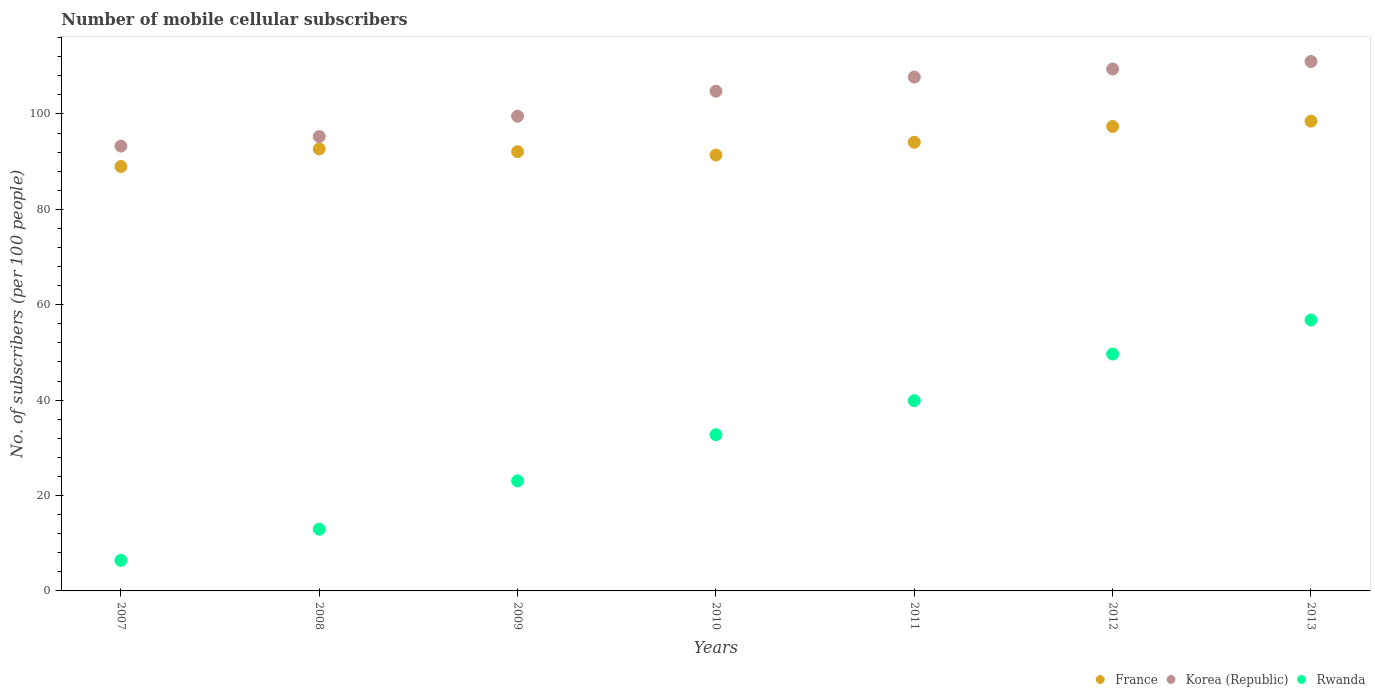How many different coloured dotlines are there?
Offer a terse response. 3. What is the number of mobile cellular subscribers in France in 2010?
Provide a succinct answer. 91.39. Across all years, what is the maximum number of mobile cellular subscribers in Korea (Republic)?
Offer a very short reply. 111. Across all years, what is the minimum number of mobile cellular subscribers in France?
Your response must be concise. 88.98. In which year was the number of mobile cellular subscribers in France maximum?
Make the answer very short. 2013. In which year was the number of mobile cellular subscribers in Korea (Republic) minimum?
Offer a very short reply. 2007. What is the total number of mobile cellular subscribers in Rwanda in the graph?
Your response must be concise. 221.52. What is the difference between the number of mobile cellular subscribers in France in 2008 and that in 2011?
Provide a short and direct response. -1.4. What is the difference between the number of mobile cellular subscribers in Rwanda in 2012 and the number of mobile cellular subscribers in France in 2010?
Ensure brevity in your answer.  -41.72. What is the average number of mobile cellular subscribers in Korea (Republic) per year?
Provide a succinct answer. 103. In the year 2012, what is the difference between the number of mobile cellular subscribers in Korea (Republic) and number of mobile cellular subscribers in Rwanda?
Your response must be concise. 59.76. In how many years, is the number of mobile cellular subscribers in Korea (Republic) greater than 24?
Give a very brief answer. 7. What is the ratio of the number of mobile cellular subscribers in France in 2009 to that in 2012?
Offer a terse response. 0.95. What is the difference between the highest and the second highest number of mobile cellular subscribers in Rwanda?
Give a very brief answer. 7.13. What is the difference between the highest and the lowest number of mobile cellular subscribers in Rwanda?
Your answer should be very brief. 50.4. In how many years, is the number of mobile cellular subscribers in France greater than the average number of mobile cellular subscribers in France taken over all years?
Make the answer very short. 3. Is the sum of the number of mobile cellular subscribers in Korea (Republic) in 2009 and 2010 greater than the maximum number of mobile cellular subscribers in France across all years?
Ensure brevity in your answer.  Yes. Is it the case that in every year, the sum of the number of mobile cellular subscribers in France and number of mobile cellular subscribers in Rwanda  is greater than the number of mobile cellular subscribers in Korea (Republic)?
Ensure brevity in your answer.  Yes. Is the number of mobile cellular subscribers in Korea (Republic) strictly greater than the number of mobile cellular subscribers in France over the years?
Your answer should be very brief. Yes. How many dotlines are there?
Your answer should be very brief. 3. How many years are there in the graph?
Offer a very short reply. 7. Are the values on the major ticks of Y-axis written in scientific E-notation?
Offer a terse response. No. How many legend labels are there?
Provide a succinct answer. 3. How are the legend labels stacked?
Offer a very short reply. Horizontal. What is the title of the graph?
Ensure brevity in your answer.  Number of mobile cellular subscribers. Does "Spain" appear as one of the legend labels in the graph?
Your answer should be compact. No. What is the label or title of the Y-axis?
Provide a succinct answer. No. of subscribers (per 100 people). What is the No. of subscribers (per 100 people) in France in 2007?
Offer a very short reply. 88.98. What is the No. of subscribers (per 100 people) in Korea (Republic) in 2007?
Offer a terse response. 93.27. What is the No. of subscribers (per 100 people) of Rwanda in 2007?
Give a very brief answer. 6.4. What is the No. of subscribers (per 100 people) in France in 2008?
Provide a short and direct response. 92.68. What is the No. of subscribers (per 100 people) in Korea (Republic) in 2008?
Offer a terse response. 95.28. What is the No. of subscribers (per 100 people) in Rwanda in 2008?
Offer a very short reply. 12.94. What is the No. of subscribers (per 100 people) of France in 2009?
Make the answer very short. 92.1. What is the No. of subscribers (per 100 people) in Korea (Republic) in 2009?
Your answer should be very brief. 99.54. What is the No. of subscribers (per 100 people) in Rwanda in 2009?
Your answer should be compact. 23.07. What is the No. of subscribers (per 100 people) of France in 2010?
Offer a very short reply. 91.39. What is the No. of subscribers (per 100 people) in Korea (Republic) in 2010?
Offer a very short reply. 104.77. What is the No. of subscribers (per 100 people) of Rwanda in 2010?
Offer a very short reply. 32.75. What is the No. of subscribers (per 100 people) of France in 2011?
Offer a very short reply. 94.08. What is the No. of subscribers (per 100 people) of Korea (Republic) in 2011?
Offer a very short reply. 107.74. What is the No. of subscribers (per 100 people) in Rwanda in 2011?
Offer a very short reply. 39.9. What is the No. of subscribers (per 100 people) in France in 2012?
Provide a short and direct response. 97.38. What is the No. of subscribers (per 100 people) of Korea (Republic) in 2012?
Make the answer very short. 109.43. What is the No. of subscribers (per 100 people) in Rwanda in 2012?
Make the answer very short. 49.67. What is the No. of subscribers (per 100 people) in France in 2013?
Ensure brevity in your answer.  98.5. What is the No. of subscribers (per 100 people) of Korea (Republic) in 2013?
Give a very brief answer. 111. What is the No. of subscribers (per 100 people) of Rwanda in 2013?
Make the answer very short. 56.8. Across all years, what is the maximum No. of subscribers (per 100 people) in France?
Your response must be concise. 98.5. Across all years, what is the maximum No. of subscribers (per 100 people) in Korea (Republic)?
Offer a very short reply. 111. Across all years, what is the maximum No. of subscribers (per 100 people) of Rwanda?
Your response must be concise. 56.8. Across all years, what is the minimum No. of subscribers (per 100 people) in France?
Provide a succinct answer. 88.98. Across all years, what is the minimum No. of subscribers (per 100 people) in Korea (Republic)?
Provide a short and direct response. 93.27. Across all years, what is the minimum No. of subscribers (per 100 people) in Rwanda?
Make the answer very short. 6.4. What is the total No. of subscribers (per 100 people) in France in the graph?
Provide a succinct answer. 655.1. What is the total No. of subscribers (per 100 people) in Korea (Republic) in the graph?
Ensure brevity in your answer.  721.03. What is the total No. of subscribers (per 100 people) in Rwanda in the graph?
Your response must be concise. 221.52. What is the difference between the No. of subscribers (per 100 people) of France in 2007 and that in 2008?
Keep it short and to the point. -3.69. What is the difference between the No. of subscribers (per 100 people) in Korea (Republic) in 2007 and that in 2008?
Give a very brief answer. -2.01. What is the difference between the No. of subscribers (per 100 people) of Rwanda in 2007 and that in 2008?
Your response must be concise. -6.54. What is the difference between the No. of subscribers (per 100 people) of France in 2007 and that in 2009?
Your answer should be very brief. -3.11. What is the difference between the No. of subscribers (per 100 people) of Korea (Republic) in 2007 and that in 2009?
Keep it short and to the point. -6.28. What is the difference between the No. of subscribers (per 100 people) in Rwanda in 2007 and that in 2009?
Offer a terse response. -16.67. What is the difference between the No. of subscribers (per 100 people) of France in 2007 and that in 2010?
Ensure brevity in your answer.  -2.4. What is the difference between the No. of subscribers (per 100 people) of Korea (Republic) in 2007 and that in 2010?
Offer a very short reply. -11.51. What is the difference between the No. of subscribers (per 100 people) of Rwanda in 2007 and that in 2010?
Provide a succinct answer. -26.35. What is the difference between the No. of subscribers (per 100 people) of France in 2007 and that in 2011?
Your response must be concise. -5.09. What is the difference between the No. of subscribers (per 100 people) of Korea (Republic) in 2007 and that in 2011?
Make the answer very short. -14.48. What is the difference between the No. of subscribers (per 100 people) of Rwanda in 2007 and that in 2011?
Ensure brevity in your answer.  -33.5. What is the difference between the No. of subscribers (per 100 people) of France in 2007 and that in 2012?
Keep it short and to the point. -8.39. What is the difference between the No. of subscribers (per 100 people) in Korea (Republic) in 2007 and that in 2012?
Your answer should be compact. -16.17. What is the difference between the No. of subscribers (per 100 people) of Rwanda in 2007 and that in 2012?
Provide a succinct answer. -43.27. What is the difference between the No. of subscribers (per 100 people) of France in 2007 and that in 2013?
Your answer should be very brief. -9.51. What is the difference between the No. of subscribers (per 100 people) of Korea (Republic) in 2007 and that in 2013?
Ensure brevity in your answer.  -17.73. What is the difference between the No. of subscribers (per 100 people) of Rwanda in 2007 and that in 2013?
Keep it short and to the point. -50.4. What is the difference between the No. of subscribers (per 100 people) in France in 2008 and that in 2009?
Make the answer very short. 0.58. What is the difference between the No. of subscribers (per 100 people) of Korea (Republic) in 2008 and that in 2009?
Offer a terse response. -4.27. What is the difference between the No. of subscribers (per 100 people) in Rwanda in 2008 and that in 2009?
Provide a succinct answer. -10.13. What is the difference between the No. of subscribers (per 100 people) of France in 2008 and that in 2010?
Give a very brief answer. 1.29. What is the difference between the No. of subscribers (per 100 people) in Korea (Republic) in 2008 and that in 2010?
Offer a terse response. -9.5. What is the difference between the No. of subscribers (per 100 people) in Rwanda in 2008 and that in 2010?
Offer a terse response. -19.81. What is the difference between the No. of subscribers (per 100 people) of France in 2008 and that in 2011?
Give a very brief answer. -1.4. What is the difference between the No. of subscribers (per 100 people) in Korea (Republic) in 2008 and that in 2011?
Give a very brief answer. -12.47. What is the difference between the No. of subscribers (per 100 people) in Rwanda in 2008 and that in 2011?
Offer a very short reply. -26.96. What is the difference between the No. of subscribers (per 100 people) in France in 2008 and that in 2012?
Offer a terse response. -4.7. What is the difference between the No. of subscribers (per 100 people) in Korea (Republic) in 2008 and that in 2012?
Provide a short and direct response. -14.15. What is the difference between the No. of subscribers (per 100 people) of Rwanda in 2008 and that in 2012?
Offer a terse response. -36.73. What is the difference between the No. of subscribers (per 100 people) in France in 2008 and that in 2013?
Ensure brevity in your answer.  -5.82. What is the difference between the No. of subscribers (per 100 people) of Korea (Republic) in 2008 and that in 2013?
Offer a very short reply. -15.72. What is the difference between the No. of subscribers (per 100 people) in Rwanda in 2008 and that in 2013?
Your answer should be very brief. -43.86. What is the difference between the No. of subscribers (per 100 people) of France in 2009 and that in 2010?
Offer a very short reply. 0.71. What is the difference between the No. of subscribers (per 100 people) in Korea (Republic) in 2009 and that in 2010?
Provide a succinct answer. -5.23. What is the difference between the No. of subscribers (per 100 people) of Rwanda in 2009 and that in 2010?
Your answer should be compact. -9.68. What is the difference between the No. of subscribers (per 100 people) of France in 2009 and that in 2011?
Offer a terse response. -1.98. What is the difference between the No. of subscribers (per 100 people) of Korea (Republic) in 2009 and that in 2011?
Make the answer very short. -8.2. What is the difference between the No. of subscribers (per 100 people) in Rwanda in 2009 and that in 2011?
Provide a succinct answer. -16.83. What is the difference between the No. of subscribers (per 100 people) in France in 2009 and that in 2012?
Ensure brevity in your answer.  -5.28. What is the difference between the No. of subscribers (per 100 people) in Korea (Republic) in 2009 and that in 2012?
Your answer should be very brief. -9.89. What is the difference between the No. of subscribers (per 100 people) of Rwanda in 2009 and that in 2012?
Make the answer very short. -26.6. What is the difference between the No. of subscribers (per 100 people) of France in 2009 and that in 2013?
Provide a short and direct response. -6.4. What is the difference between the No. of subscribers (per 100 people) in Korea (Republic) in 2009 and that in 2013?
Keep it short and to the point. -11.46. What is the difference between the No. of subscribers (per 100 people) in Rwanda in 2009 and that in 2013?
Provide a short and direct response. -33.73. What is the difference between the No. of subscribers (per 100 people) in France in 2010 and that in 2011?
Provide a short and direct response. -2.69. What is the difference between the No. of subscribers (per 100 people) of Korea (Republic) in 2010 and that in 2011?
Give a very brief answer. -2.97. What is the difference between the No. of subscribers (per 100 people) of Rwanda in 2010 and that in 2011?
Ensure brevity in your answer.  -7.15. What is the difference between the No. of subscribers (per 100 people) in France in 2010 and that in 2012?
Provide a succinct answer. -5.99. What is the difference between the No. of subscribers (per 100 people) of Korea (Republic) in 2010 and that in 2012?
Give a very brief answer. -4.66. What is the difference between the No. of subscribers (per 100 people) in Rwanda in 2010 and that in 2012?
Ensure brevity in your answer.  -16.92. What is the difference between the No. of subscribers (per 100 people) of France in 2010 and that in 2013?
Provide a short and direct response. -7.11. What is the difference between the No. of subscribers (per 100 people) in Korea (Republic) in 2010 and that in 2013?
Offer a very short reply. -6.22. What is the difference between the No. of subscribers (per 100 people) of Rwanda in 2010 and that in 2013?
Provide a succinct answer. -24.05. What is the difference between the No. of subscribers (per 100 people) in France in 2011 and that in 2012?
Your response must be concise. -3.3. What is the difference between the No. of subscribers (per 100 people) in Korea (Republic) in 2011 and that in 2012?
Your answer should be compact. -1.69. What is the difference between the No. of subscribers (per 100 people) in Rwanda in 2011 and that in 2012?
Offer a very short reply. -9.77. What is the difference between the No. of subscribers (per 100 people) of France in 2011 and that in 2013?
Your response must be concise. -4.42. What is the difference between the No. of subscribers (per 100 people) in Korea (Republic) in 2011 and that in 2013?
Ensure brevity in your answer.  -3.25. What is the difference between the No. of subscribers (per 100 people) in Rwanda in 2011 and that in 2013?
Keep it short and to the point. -16.9. What is the difference between the No. of subscribers (per 100 people) of France in 2012 and that in 2013?
Keep it short and to the point. -1.12. What is the difference between the No. of subscribers (per 100 people) in Korea (Republic) in 2012 and that in 2013?
Ensure brevity in your answer.  -1.57. What is the difference between the No. of subscribers (per 100 people) of Rwanda in 2012 and that in 2013?
Offer a terse response. -7.13. What is the difference between the No. of subscribers (per 100 people) in France in 2007 and the No. of subscribers (per 100 people) in Korea (Republic) in 2008?
Offer a very short reply. -6.29. What is the difference between the No. of subscribers (per 100 people) of France in 2007 and the No. of subscribers (per 100 people) of Rwanda in 2008?
Give a very brief answer. 76.05. What is the difference between the No. of subscribers (per 100 people) in Korea (Republic) in 2007 and the No. of subscribers (per 100 people) in Rwanda in 2008?
Ensure brevity in your answer.  80.33. What is the difference between the No. of subscribers (per 100 people) of France in 2007 and the No. of subscribers (per 100 people) of Korea (Republic) in 2009?
Give a very brief answer. -10.56. What is the difference between the No. of subscribers (per 100 people) in France in 2007 and the No. of subscribers (per 100 people) in Rwanda in 2009?
Ensure brevity in your answer.  65.91. What is the difference between the No. of subscribers (per 100 people) of Korea (Republic) in 2007 and the No. of subscribers (per 100 people) of Rwanda in 2009?
Offer a terse response. 70.2. What is the difference between the No. of subscribers (per 100 people) of France in 2007 and the No. of subscribers (per 100 people) of Korea (Republic) in 2010?
Provide a short and direct response. -15.79. What is the difference between the No. of subscribers (per 100 people) of France in 2007 and the No. of subscribers (per 100 people) of Rwanda in 2010?
Provide a succinct answer. 56.24. What is the difference between the No. of subscribers (per 100 people) of Korea (Republic) in 2007 and the No. of subscribers (per 100 people) of Rwanda in 2010?
Make the answer very short. 60.52. What is the difference between the No. of subscribers (per 100 people) in France in 2007 and the No. of subscribers (per 100 people) in Korea (Republic) in 2011?
Offer a very short reply. -18.76. What is the difference between the No. of subscribers (per 100 people) of France in 2007 and the No. of subscribers (per 100 people) of Rwanda in 2011?
Ensure brevity in your answer.  49.09. What is the difference between the No. of subscribers (per 100 people) of Korea (Republic) in 2007 and the No. of subscribers (per 100 people) of Rwanda in 2011?
Your answer should be very brief. 53.37. What is the difference between the No. of subscribers (per 100 people) in France in 2007 and the No. of subscribers (per 100 people) in Korea (Republic) in 2012?
Your answer should be compact. -20.45. What is the difference between the No. of subscribers (per 100 people) in France in 2007 and the No. of subscribers (per 100 people) in Rwanda in 2012?
Keep it short and to the point. 39.32. What is the difference between the No. of subscribers (per 100 people) in Korea (Republic) in 2007 and the No. of subscribers (per 100 people) in Rwanda in 2012?
Provide a short and direct response. 43.6. What is the difference between the No. of subscribers (per 100 people) of France in 2007 and the No. of subscribers (per 100 people) of Korea (Republic) in 2013?
Provide a succinct answer. -22.01. What is the difference between the No. of subscribers (per 100 people) of France in 2007 and the No. of subscribers (per 100 people) of Rwanda in 2013?
Offer a very short reply. 32.18. What is the difference between the No. of subscribers (per 100 people) of Korea (Republic) in 2007 and the No. of subscribers (per 100 people) of Rwanda in 2013?
Provide a succinct answer. 36.47. What is the difference between the No. of subscribers (per 100 people) in France in 2008 and the No. of subscribers (per 100 people) in Korea (Republic) in 2009?
Ensure brevity in your answer.  -6.86. What is the difference between the No. of subscribers (per 100 people) in France in 2008 and the No. of subscribers (per 100 people) in Rwanda in 2009?
Make the answer very short. 69.61. What is the difference between the No. of subscribers (per 100 people) in Korea (Republic) in 2008 and the No. of subscribers (per 100 people) in Rwanda in 2009?
Offer a terse response. 72.21. What is the difference between the No. of subscribers (per 100 people) of France in 2008 and the No. of subscribers (per 100 people) of Korea (Republic) in 2010?
Make the answer very short. -12.1. What is the difference between the No. of subscribers (per 100 people) of France in 2008 and the No. of subscribers (per 100 people) of Rwanda in 2010?
Provide a short and direct response. 59.93. What is the difference between the No. of subscribers (per 100 people) in Korea (Republic) in 2008 and the No. of subscribers (per 100 people) in Rwanda in 2010?
Your answer should be compact. 62.53. What is the difference between the No. of subscribers (per 100 people) of France in 2008 and the No. of subscribers (per 100 people) of Korea (Republic) in 2011?
Your answer should be compact. -15.07. What is the difference between the No. of subscribers (per 100 people) of France in 2008 and the No. of subscribers (per 100 people) of Rwanda in 2011?
Ensure brevity in your answer.  52.78. What is the difference between the No. of subscribers (per 100 people) in Korea (Republic) in 2008 and the No. of subscribers (per 100 people) in Rwanda in 2011?
Offer a terse response. 55.38. What is the difference between the No. of subscribers (per 100 people) in France in 2008 and the No. of subscribers (per 100 people) in Korea (Republic) in 2012?
Your response must be concise. -16.75. What is the difference between the No. of subscribers (per 100 people) in France in 2008 and the No. of subscribers (per 100 people) in Rwanda in 2012?
Your answer should be very brief. 43.01. What is the difference between the No. of subscribers (per 100 people) of Korea (Republic) in 2008 and the No. of subscribers (per 100 people) of Rwanda in 2012?
Provide a short and direct response. 45.61. What is the difference between the No. of subscribers (per 100 people) in France in 2008 and the No. of subscribers (per 100 people) in Korea (Republic) in 2013?
Provide a short and direct response. -18.32. What is the difference between the No. of subscribers (per 100 people) of France in 2008 and the No. of subscribers (per 100 people) of Rwanda in 2013?
Your response must be concise. 35.88. What is the difference between the No. of subscribers (per 100 people) of Korea (Republic) in 2008 and the No. of subscribers (per 100 people) of Rwanda in 2013?
Keep it short and to the point. 38.48. What is the difference between the No. of subscribers (per 100 people) in France in 2009 and the No. of subscribers (per 100 people) in Korea (Republic) in 2010?
Your answer should be compact. -12.68. What is the difference between the No. of subscribers (per 100 people) of France in 2009 and the No. of subscribers (per 100 people) of Rwanda in 2010?
Offer a very short reply. 59.35. What is the difference between the No. of subscribers (per 100 people) of Korea (Republic) in 2009 and the No. of subscribers (per 100 people) of Rwanda in 2010?
Make the answer very short. 66.79. What is the difference between the No. of subscribers (per 100 people) of France in 2009 and the No. of subscribers (per 100 people) of Korea (Republic) in 2011?
Offer a terse response. -15.65. What is the difference between the No. of subscribers (per 100 people) in France in 2009 and the No. of subscribers (per 100 people) in Rwanda in 2011?
Your answer should be compact. 52.2. What is the difference between the No. of subscribers (per 100 people) in Korea (Republic) in 2009 and the No. of subscribers (per 100 people) in Rwanda in 2011?
Provide a short and direct response. 59.65. What is the difference between the No. of subscribers (per 100 people) in France in 2009 and the No. of subscribers (per 100 people) in Korea (Republic) in 2012?
Make the answer very short. -17.34. What is the difference between the No. of subscribers (per 100 people) of France in 2009 and the No. of subscribers (per 100 people) of Rwanda in 2012?
Give a very brief answer. 42.43. What is the difference between the No. of subscribers (per 100 people) in Korea (Republic) in 2009 and the No. of subscribers (per 100 people) in Rwanda in 2012?
Your response must be concise. 49.87. What is the difference between the No. of subscribers (per 100 people) in France in 2009 and the No. of subscribers (per 100 people) in Korea (Republic) in 2013?
Your answer should be very brief. -18.9. What is the difference between the No. of subscribers (per 100 people) of France in 2009 and the No. of subscribers (per 100 people) of Rwanda in 2013?
Give a very brief answer. 35.3. What is the difference between the No. of subscribers (per 100 people) in Korea (Republic) in 2009 and the No. of subscribers (per 100 people) in Rwanda in 2013?
Offer a terse response. 42.74. What is the difference between the No. of subscribers (per 100 people) of France in 2010 and the No. of subscribers (per 100 people) of Korea (Republic) in 2011?
Your response must be concise. -16.36. What is the difference between the No. of subscribers (per 100 people) in France in 2010 and the No. of subscribers (per 100 people) in Rwanda in 2011?
Your answer should be compact. 51.49. What is the difference between the No. of subscribers (per 100 people) of Korea (Republic) in 2010 and the No. of subscribers (per 100 people) of Rwanda in 2011?
Ensure brevity in your answer.  64.88. What is the difference between the No. of subscribers (per 100 people) in France in 2010 and the No. of subscribers (per 100 people) in Korea (Republic) in 2012?
Keep it short and to the point. -18.04. What is the difference between the No. of subscribers (per 100 people) of France in 2010 and the No. of subscribers (per 100 people) of Rwanda in 2012?
Keep it short and to the point. 41.72. What is the difference between the No. of subscribers (per 100 people) in Korea (Republic) in 2010 and the No. of subscribers (per 100 people) in Rwanda in 2012?
Your answer should be compact. 55.11. What is the difference between the No. of subscribers (per 100 people) in France in 2010 and the No. of subscribers (per 100 people) in Korea (Republic) in 2013?
Offer a terse response. -19.61. What is the difference between the No. of subscribers (per 100 people) in France in 2010 and the No. of subscribers (per 100 people) in Rwanda in 2013?
Keep it short and to the point. 34.59. What is the difference between the No. of subscribers (per 100 people) in Korea (Republic) in 2010 and the No. of subscribers (per 100 people) in Rwanda in 2013?
Your answer should be very brief. 47.97. What is the difference between the No. of subscribers (per 100 people) in France in 2011 and the No. of subscribers (per 100 people) in Korea (Republic) in 2012?
Your answer should be very brief. -15.35. What is the difference between the No. of subscribers (per 100 people) of France in 2011 and the No. of subscribers (per 100 people) of Rwanda in 2012?
Make the answer very short. 44.41. What is the difference between the No. of subscribers (per 100 people) of Korea (Republic) in 2011 and the No. of subscribers (per 100 people) of Rwanda in 2012?
Keep it short and to the point. 58.08. What is the difference between the No. of subscribers (per 100 people) of France in 2011 and the No. of subscribers (per 100 people) of Korea (Republic) in 2013?
Keep it short and to the point. -16.92. What is the difference between the No. of subscribers (per 100 people) of France in 2011 and the No. of subscribers (per 100 people) of Rwanda in 2013?
Provide a succinct answer. 37.28. What is the difference between the No. of subscribers (per 100 people) in Korea (Republic) in 2011 and the No. of subscribers (per 100 people) in Rwanda in 2013?
Your answer should be very brief. 50.94. What is the difference between the No. of subscribers (per 100 people) in France in 2012 and the No. of subscribers (per 100 people) in Korea (Republic) in 2013?
Offer a very short reply. -13.62. What is the difference between the No. of subscribers (per 100 people) of France in 2012 and the No. of subscribers (per 100 people) of Rwanda in 2013?
Make the answer very short. 40.58. What is the difference between the No. of subscribers (per 100 people) of Korea (Republic) in 2012 and the No. of subscribers (per 100 people) of Rwanda in 2013?
Offer a very short reply. 52.63. What is the average No. of subscribers (per 100 people) of France per year?
Provide a short and direct response. 93.59. What is the average No. of subscribers (per 100 people) in Korea (Republic) per year?
Offer a terse response. 103. What is the average No. of subscribers (per 100 people) in Rwanda per year?
Ensure brevity in your answer.  31.65. In the year 2007, what is the difference between the No. of subscribers (per 100 people) of France and No. of subscribers (per 100 people) of Korea (Republic)?
Make the answer very short. -4.28. In the year 2007, what is the difference between the No. of subscribers (per 100 people) in France and No. of subscribers (per 100 people) in Rwanda?
Ensure brevity in your answer.  82.59. In the year 2007, what is the difference between the No. of subscribers (per 100 people) in Korea (Republic) and No. of subscribers (per 100 people) in Rwanda?
Ensure brevity in your answer.  86.87. In the year 2008, what is the difference between the No. of subscribers (per 100 people) in France and No. of subscribers (per 100 people) in Korea (Republic)?
Offer a very short reply. -2.6. In the year 2008, what is the difference between the No. of subscribers (per 100 people) of France and No. of subscribers (per 100 people) of Rwanda?
Provide a succinct answer. 79.74. In the year 2008, what is the difference between the No. of subscribers (per 100 people) in Korea (Republic) and No. of subscribers (per 100 people) in Rwanda?
Offer a terse response. 82.34. In the year 2009, what is the difference between the No. of subscribers (per 100 people) of France and No. of subscribers (per 100 people) of Korea (Republic)?
Provide a short and direct response. -7.45. In the year 2009, what is the difference between the No. of subscribers (per 100 people) of France and No. of subscribers (per 100 people) of Rwanda?
Provide a succinct answer. 69.03. In the year 2009, what is the difference between the No. of subscribers (per 100 people) in Korea (Republic) and No. of subscribers (per 100 people) in Rwanda?
Your response must be concise. 76.47. In the year 2010, what is the difference between the No. of subscribers (per 100 people) in France and No. of subscribers (per 100 people) in Korea (Republic)?
Make the answer very short. -13.39. In the year 2010, what is the difference between the No. of subscribers (per 100 people) in France and No. of subscribers (per 100 people) in Rwanda?
Offer a very short reply. 58.64. In the year 2010, what is the difference between the No. of subscribers (per 100 people) in Korea (Republic) and No. of subscribers (per 100 people) in Rwanda?
Ensure brevity in your answer.  72.03. In the year 2011, what is the difference between the No. of subscribers (per 100 people) in France and No. of subscribers (per 100 people) in Korea (Republic)?
Give a very brief answer. -13.67. In the year 2011, what is the difference between the No. of subscribers (per 100 people) in France and No. of subscribers (per 100 people) in Rwanda?
Ensure brevity in your answer.  54.18. In the year 2011, what is the difference between the No. of subscribers (per 100 people) in Korea (Republic) and No. of subscribers (per 100 people) in Rwanda?
Your answer should be compact. 67.85. In the year 2012, what is the difference between the No. of subscribers (per 100 people) of France and No. of subscribers (per 100 people) of Korea (Republic)?
Offer a terse response. -12.05. In the year 2012, what is the difference between the No. of subscribers (per 100 people) of France and No. of subscribers (per 100 people) of Rwanda?
Your response must be concise. 47.71. In the year 2012, what is the difference between the No. of subscribers (per 100 people) of Korea (Republic) and No. of subscribers (per 100 people) of Rwanda?
Ensure brevity in your answer.  59.76. In the year 2013, what is the difference between the No. of subscribers (per 100 people) of France and No. of subscribers (per 100 people) of Korea (Republic)?
Your answer should be very brief. -12.5. In the year 2013, what is the difference between the No. of subscribers (per 100 people) of France and No. of subscribers (per 100 people) of Rwanda?
Your answer should be very brief. 41.69. In the year 2013, what is the difference between the No. of subscribers (per 100 people) of Korea (Republic) and No. of subscribers (per 100 people) of Rwanda?
Ensure brevity in your answer.  54.2. What is the ratio of the No. of subscribers (per 100 people) of France in 2007 to that in 2008?
Provide a succinct answer. 0.96. What is the ratio of the No. of subscribers (per 100 people) in Korea (Republic) in 2007 to that in 2008?
Offer a terse response. 0.98. What is the ratio of the No. of subscribers (per 100 people) of Rwanda in 2007 to that in 2008?
Ensure brevity in your answer.  0.49. What is the ratio of the No. of subscribers (per 100 people) in France in 2007 to that in 2009?
Your answer should be very brief. 0.97. What is the ratio of the No. of subscribers (per 100 people) in Korea (Republic) in 2007 to that in 2009?
Offer a very short reply. 0.94. What is the ratio of the No. of subscribers (per 100 people) of Rwanda in 2007 to that in 2009?
Provide a succinct answer. 0.28. What is the ratio of the No. of subscribers (per 100 people) of France in 2007 to that in 2010?
Your answer should be compact. 0.97. What is the ratio of the No. of subscribers (per 100 people) of Korea (Republic) in 2007 to that in 2010?
Offer a very short reply. 0.89. What is the ratio of the No. of subscribers (per 100 people) of Rwanda in 2007 to that in 2010?
Provide a short and direct response. 0.2. What is the ratio of the No. of subscribers (per 100 people) of France in 2007 to that in 2011?
Your answer should be very brief. 0.95. What is the ratio of the No. of subscribers (per 100 people) in Korea (Republic) in 2007 to that in 2011?
Make the answer very short. 0.87. What is the ratio of the No. of subscribers (per 100 people) in Rwanda in 2007 to that in 2011?
Your response must be concise. 0.16. What is the ratio of the No. of subscribers (per 100 people) of France in 2007 to that in 2012?
Provide a succinct answer. 0.91. What is the ratio of the No. of subscribers (per 100 people) in Korea (Republic) in 2007 to that in 2012?
Your answer should be compact. 0.85. What is the ratio of the No. of subscribers (per 100 people) of Rwanda in 2007 to that in 2012?
Your answer should be compact. 0.13. What is the ratio of the No. of subscribers (per 100 people) in France in 2007 to that in 2013?
Provide a succinct answer. 0.9. What is the ratio of the No. of subscribers (per 100 people) in Korea (Republic) in 2007 to that in 2013?
Offer a very short reply. 0.84. What is the ratio of the No. of subscribers (per 100 people) in Rwanda in 2007 to that in 2013?
Your answer should be compact. 0.11. What is the ratio of the No. of subscribers (per 100 people) in Korea (Republic) in 2008 to that in 2009?
Provide a succinct answer. 0.96. What is the ratio of the No. of subscribers (per 100 people) in Rwanda in 2008 to that in 2009?
Your answer should be compact. 0.56. What is the ratio of the No. of subscribers (per 100 people) of France in 2008 to that in 2010?
Provide a succinct answer. 1.01. What is the ratio of the No. of subscribers (per 100 people) of Korea (Republic) in 2008 to that in 2010?
Keep it short and to the point. 0.91. What is the ratio of the No. of subscribers (per 100 people) in Rwanda in 2008 to that in 2010?
Provide a succinct answer. 0.4. What is the ratio of the No. of subscribers (per 100 people) in France in 2008 to that in 2011?
Offer a very short reply. 0.99. What is the ratio of the No. of subscribers (per 100 people) in Korea (Republic) in 2008 to that in 2011?
Provide a short and direct response. 0.88. What is the ratio of the No. of subscribers (per 100 people) of Rwanda in 2008 to that in 2011?
Your answer should be very brief. 0.32. What is the ratio of the No. of subscribers (per 100 people) in France in 2008 to that in 2012?
Offer a terse response. 0.95. What is the ratio of the No. of subscribers (per 100 people) in Korea (Republic) in 2008 to that in 2012?
Make the answer very short. 0.87. What is the ratio of the No. of subscribers (per 100 people) in Rwanda in 2008 to that in 2012?
Keep it short and to the point. 0.26. What is the ratio of the No. of subscribers (per 100 people) in France in 2008 to that in 2013?
Ensure brevity in your answer.  0.94. What is the ratio of the No. of subscribers (per 100 people) of Korea (Republic) in 2008 to that in 2013?
Provide a short and direct response. 0.86. What is the ratio of the No. of subscribers (per 100 people) of Rwanda in 2008 to that in 2013?
Provide a short and direct response. 0.23. What is the ratio of the No. of subscribers (per 100 people) in France in 2009 to that in 2010?
Your response must be concise. 1.01. What is the ratio of the No. of subscribers (per 100 people) in Korea (Republic) in 2009 to that in 2010?
Your response must be concise. 0.95. What is the ratio of the No. of subscribers (per 100 people) in Rwanda in 2009 to that in 2010?
Your response must be concise. 0.7. What is the ratio of the No. of subscribers (per 100 people) of Korea (Republic) in 2009 to that in 2011?
Offer a terse response. 0.92. What is the ratio of the No. of subscribers (per 100 people) of Rwanda in 2009 to that in 2011?
Your answer should be compact. 0.58. What is the ratio of the No. of subscribers (per 100 people) in France in 2009 to that in 2012?
Ensure brevity in your answer.  0.95. What is the ratio of the No. of subscribers (per 100 people) in Korea (Republic) in 2009 to that in 2012?
Ensure brevity in your answer.  0.91. What is the ratio of the No. of subscribers (per 100 people) in Rwanda in 2009 to that in 2012?
Your answer should be compact. 0.46. What is the ratio of the No. of subscribers (per 100 people) of France in 2009 to that in 2013?
Your answer should be compact. 0.94. What is the ratio of the No. of subscribers (per 100 people) in Korea (Republic) in 2009 to that in 2013?
Provide a succinct answer. 0.9. What is the ratio of the No. of subscribers (per 100 people) in Rwanda in 2009 to that in 2013?
Ensure brevity in your answer.  0.41. What is the ratio of the No. of subscribers (per 100 people) of France in 2010 to that in 2011?
Provide a succinct answer. 0.97. What is the ratio of the No. of subscribers (per 100 people) of Korea (Republic) in 2010 to that in 2011?
Ensure brevity in your answer.  0.97. What is the ratio of the No. of subscribers (per 100 people) of Rwanda in 2010 to that in 2011?
Ensure brevity in your answer.  0.82. What is the ratio of the No. of subscribers (per 100 people) of France in 2010 to that in 2012?
Provide a succinct answer. 0.94. What is the ratio of the No. of subscribers (per 100 people) of Korea (Republic) in 2010 to that in 2012?
Offer a very short reply. 0.96. What is the ratio of the No. of subscribers (per 100 people) of Rwanda in 2010 to that in 2012?
Keep it short and to the point. 0.66. What is the ratio of the No. of subscribers (per 100 people) of France in 2010 to that in 2013?
Keep it short and to the point. 0.93. What is the ratio of the No. of subscribers (per 100 people) in Korea (Republic) in 2010 to that in 2013?
Offer a terse response. 0.94. What is the ratio of the No. of subscribers (per 100 people) of Rwanda in 2010 to that in 2013?
Offer a very short reply. 0.58. What is the ratio of the No. of subscribers (per 100 people) in France in 2011 to that in 2012?
Offer a very short reply. 0.97. What is the ratio of the No. of subscribers (per 100 people) in Korea (Republic) in 2011 to that in 2012?
Provide a succinct answer. 0.98. What is the ratio of the No. of subscribers (per 100 people) in Rwanda in 2011 to that in 2012?
Offer a very short reply. 0.8. What is the ratio of the No. of subscribers (per 100 people) in France in 2011 to that in 2013?
Offer a very short reply. 0.96. What is the ratio of the No. of subscribers (per 100 people) in Korea (Republic) in 2011 to that in 2013?
Provide a succinct answer. 0.97. What is the ratio of the No. of subscribers (per 100 people) of Rwanda in 2011 to that in 2013?
Give a very brief answer. 0.7. What is the ratio of the No. of subscribers (per 100 people) in France in 2012 to that in 2013?
Your answer should be compact. 0.99. What is the ratio of the No. of subscribers (per 100 people) in Korea (Republic) in 2012 to that in 2013?
Ensure brevity in your answer.  0.99. What is the ratio of the No. of subscribers (per 100 people) in Rwanda in 2012 to that in 2013?
Provide a short and direct response. 0.87. What is the difference between the highest and the second highest No. of subscribers (per 100 people) in France?
Give a very brief answer. 1.12. What is the difference between the highest and the second highest No. of subscribers (per 100 people) of Korea (Republic)?
Ensure brevity in your answer.  1.57. What is the difference between the highest and the second highest No. of subscribers (per 100 people) of Rwanda?
Offer a very short reply. 7.13. What is the difference between the highest and the lowest No. of subscribers (per 100 people) in France?
Offer a terse response. 9.51. What is the difference between the highest and the lowest No. of subscribers (per 100 people) in Korea (Republic)?
Provide a succinct answer. 17.73. What is the difference between the highest and the lowest No. of subscribers (per 100 people) of Rwanda?
Give a very brief answer. 50.4. 